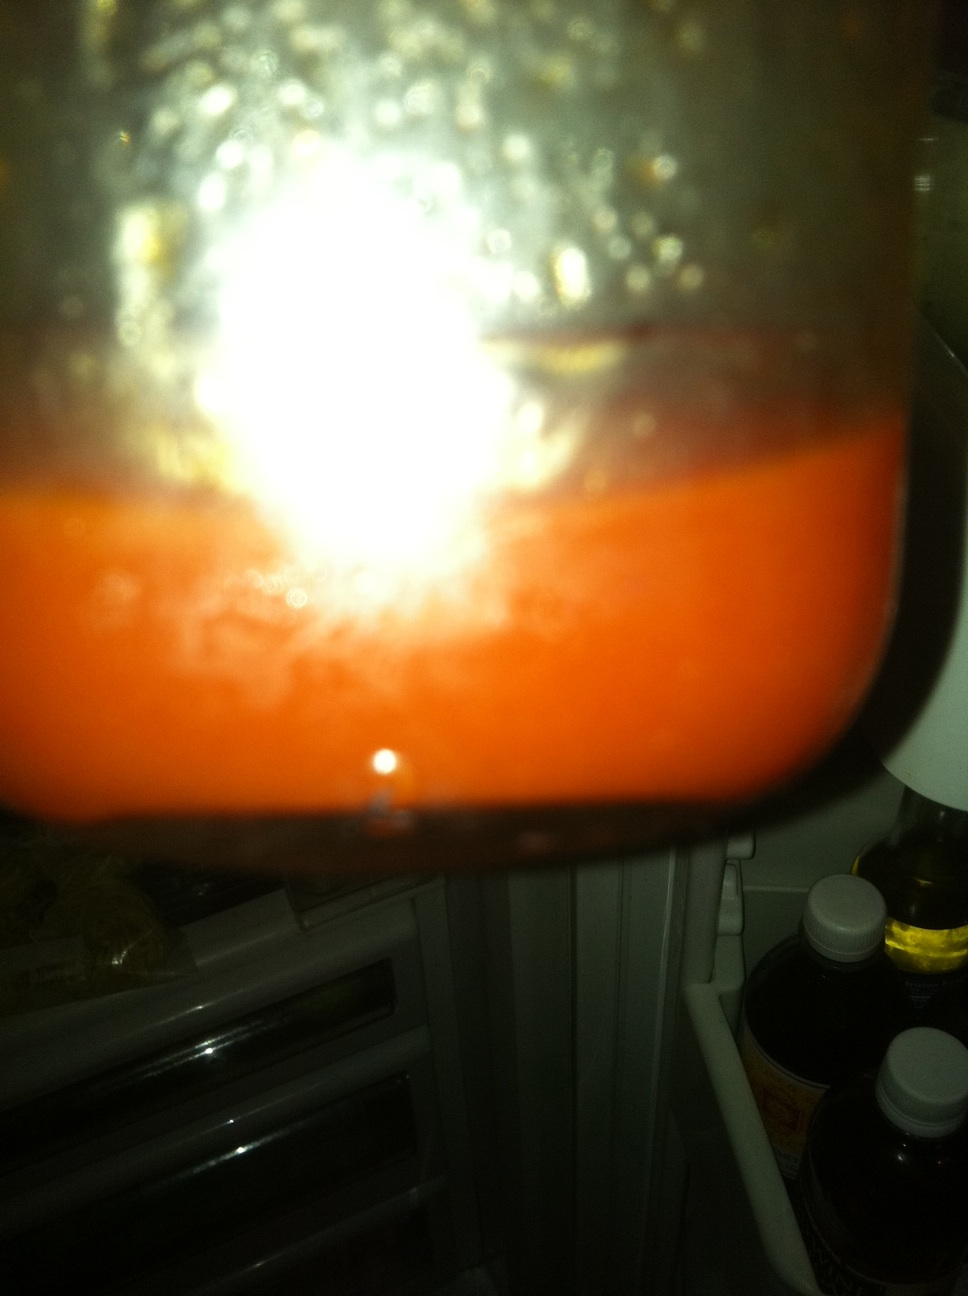Is it common to store this type of dressing in the fridge? Yes, it is common to refrigerate dressings, especially if they are homemade or contain fresh ingredients, to maintain freshness and prevent spoilage. How long can it typically be stored before going bad? Homemade dressings typically last about 1-2 weeks in the refrigerator. The exact shelf life can vary based on the ingredients used and how it's prepared. 